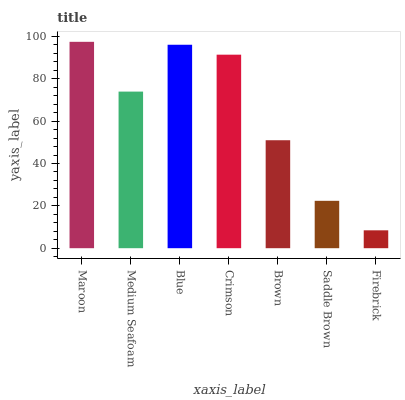Is Firebrick the minimum?
Answer yes or no. Yes. Is Maroon the maximum?
Answer yes or no. Yes. Is Medium Seafoam the minimum?
Answer yes or no. No. Is Medium Seafoam the maximum?
Answer yes or no. No. Is Maroon greater than Medium Seafoam?
Answer yes or no. Yes. Is Medium Seafoam less than Maroon?
Answer yes or no. Yes. Is Medium Seafoam greater than Maroon?
Answer yes or no. No. Is Maroon less than Medium Seafoam?
Answer yes or no. No. Is Medium Seafoam the high median?
Answer yes or no. Yes. Is Medium Seafoam the low median?
Answer yes or no. Yes. Is Blue the high median?
Answer yes or no. No. Is Crimson the low median?
Answer yes or no. No. 